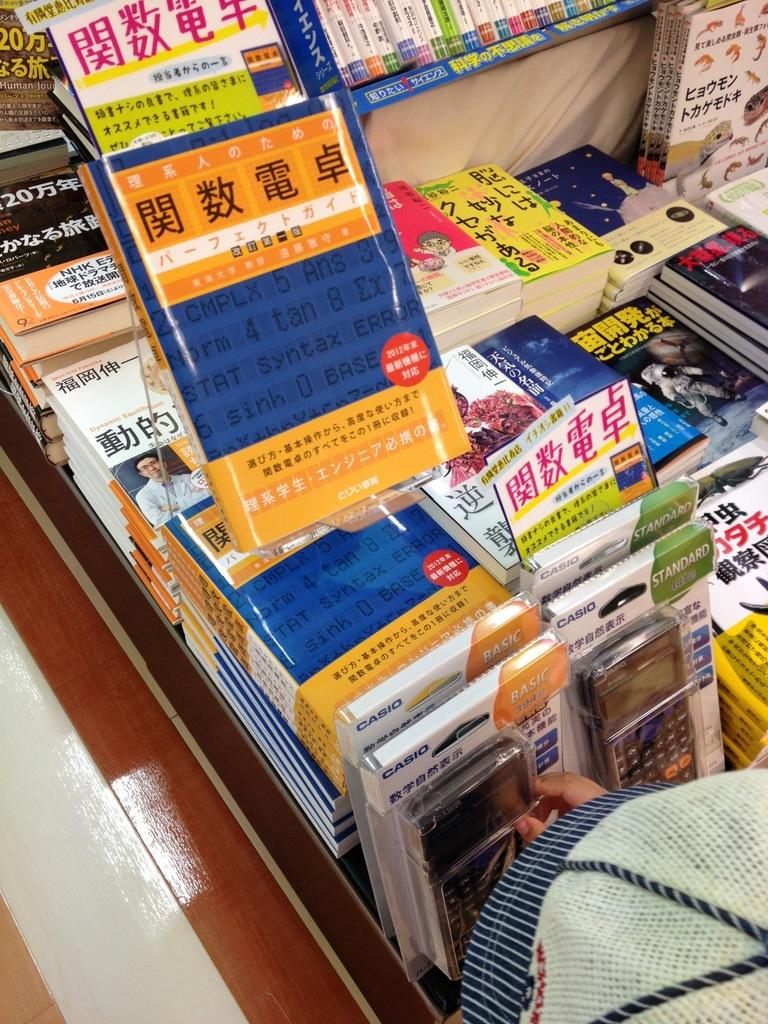What is the main subject of the image? The main subject of the image is many books. How are the books arranged in the image? The books are arranged one after the other in the middle of the image. What other objects can be seen at the bottom of the image? There are calculators at the bottom of the image. What type of silver ticket can be seen in the image? There is no silver ticket present in the image. What room is the image taken in? The provided facts do not give any information about the room or location where the image was taken. 